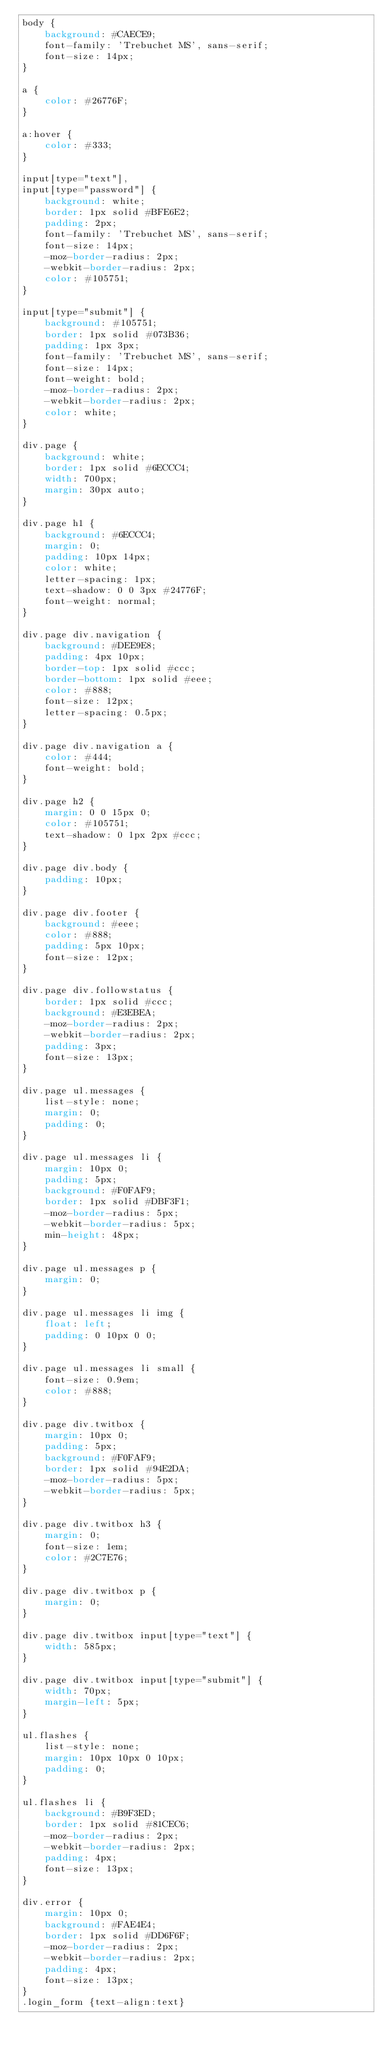<code> <loc_0><loc_0><loc_500><loc_500><_CSS_>body {
    background: #CAECE9;
    font-family: 'Trebuchet MS', sans-serif;
    font-size: 14px;
}

a {
    color: #26776F;
}

a:hover {
    color: #333;
}

input[type="text"],
input[type="password"] {
    background: white;
    border: 1px solid #BFE6E2;
    padding: 2px;
    font-family: 'Trebuchet MS', sans-serif;
    font-size: 14px;
    -moz-border-radius: 2px;
    -webkit-border-radius: 2px;
    color: #105751;
}

input[type="submit"] {
    background: #105751;
    border: 1px solid #073B36;
    padding: 1px 3px;
    font-family: 'Trebuchet MS', sans-serif;
    font-size: 14px;
    font-weight: bold;
    -moz-border-radius: 2px;
    -webkit-border-radius: 2px;
    color: white;
}

div.page {
    background: white;
    border: 1px solid #6ECCC4;
    width: 700px;
    margin: 30px auto;
}

div.page h1 {
    background: #6ECCC4;
    margin: 0;
    padding: 10px 14px;
    color: white;
    letter-spacing: 1px;
    text-shadow: 0 0 3px #24776F;
    font-weight: normal;
}

div.page div.navigation {
    background: #DEE9E8;
    padding: 4px 10px;
    border-top: 1px solid #ccc;
    border-bottom: 1px solid #eee;
    color: #888;
    font-size: 12px;
    letter-spacing: 0.5px;
}

div.page div.navigation a {
    color: #444;
    font-weight: bold;
}

div.page h2 {
    margin: 0 0 15px 0;
    color: #105751;
    text-shadow: 0 1px 2px #ccc;
}

div.page div.body {
    padding: 10px;
}

div.page div.footer {
    background: #eee;
    color: #888;
    padding: 5px 10px;
    font-size: 12px;
}

div.page div.followstatus {
    border: 1px solid #ccc;
    background: #E3EBEA;
    -moz-border-radius: 2px;
    -webkit-border-radius: 2px;
    padding: 3px;
    font-size: 13px;
}

div.page ul.messages {
    list-style: none;
    margin: 0;
    padding: 0;
}

div.page ul.messages li {
    margin: 10px 0;
    padding: 5px;
    background: #F0FAF9;
    border: 1px solid #DBF3F1;
    -moz-border-radius: 5px;
    -webkit-border-radius: 5px;
    min-height: 48px;
}

div.page ul.messages p {
    margin: 0;
}

div.page ul.messages li img {
    float: left;
    padding: 0 10px 0 0;
}

div.page ul.messages li small {
    font-size: 0.9em;
    color: #888;
}

div.page div.twitbox {
    margin: 10px 0;
    padding: 5px;
    background: #F0FAF9;
    border: 1px solid #94E2DA;
    -moz-border-radius: 5px;
    -webkit-border-radius: 5px;
}

div.page div.twitbox h3 {
    margin: 0;
    font-size: 1em;
    color: #2C7E76;
}

div.page div.twitbox p {
    margin: 0;
}

div.page div.twitbox input[type="text"] {
    width: 585px;
}

div.page div.twitbox input[type="submit"] {
    width: 70px;
    margin-left: 5px;
}

ul.flashes {
    list-style: none;
    margin: 10px 10px 0 10px;
    padding: 0;
}

ul.flashes li {
    background: #B9F3ED;
    border: 1px solid #81CEC6;
    -moz-border-radius: 2px;
    -webkit-border-radius: 2px;
    padding: 4px;
    font-size: 13px;
}

div.error {
    margin: 10px 0;
    background: #FAE4E4;
    border: 1px solid #DD6F6F;
    -moz-border-radius: 2px;
    -webkit-border-radius: 2px;
    padding: 4px;
    font-size: 13px;
}
.login_form {text-align:text}
</code> 